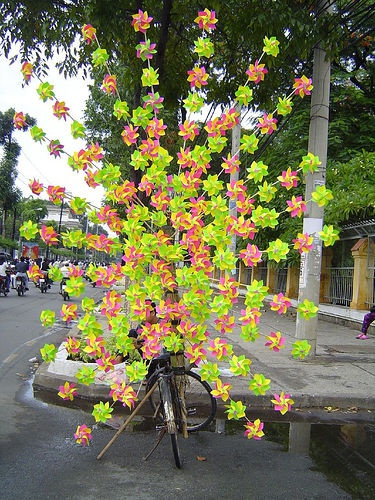Describe the objects in this image and their specific colors. I can see bicycle in black, gray, and darkgray tones, people in black, purple, navy, and gray tones, people in black, navy, and gray tones, people in black, navy, lavender, and darkgray tones, and motorcycle in black, gray, darkgray, and lightgray tones in this image. 